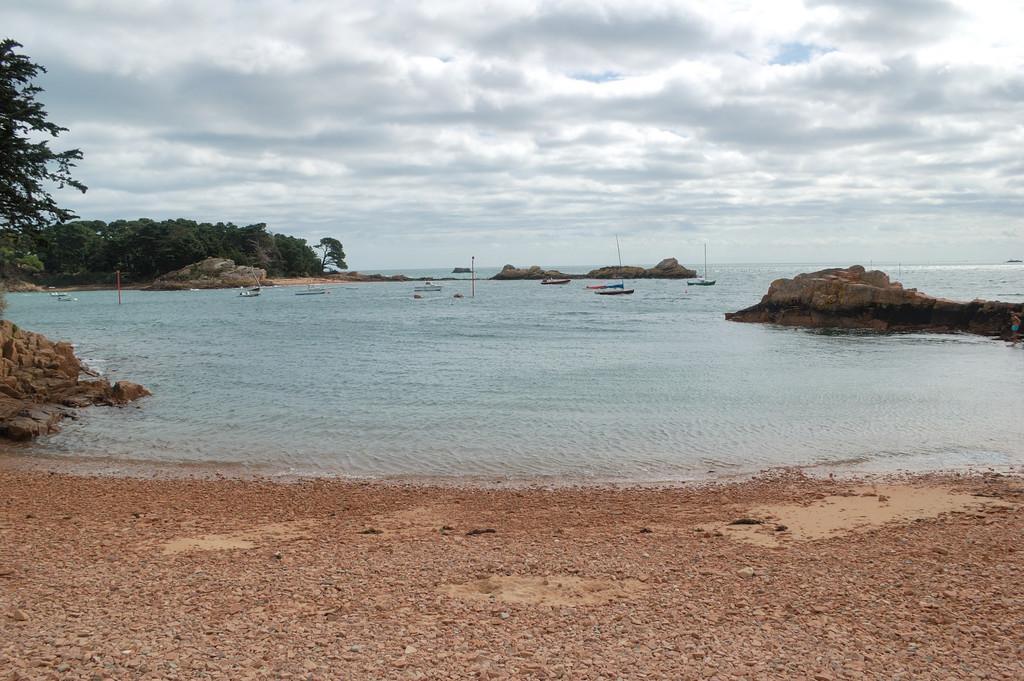In one or two sentences, can you explain what this image depicts? In this picture in the center there is water lake and there are boats sailing on the water. On the left side there are trees and on the right side there are rocks on the water and the sky is cloudy. 